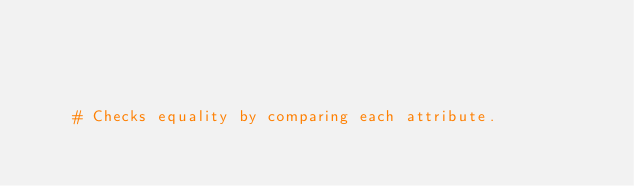Convert code to text. <code><loc_0><loc_0><loc_500><loc_500><_Ruby_>    
    
    
    
    # Checks equality by comparing each attribute.</code> 